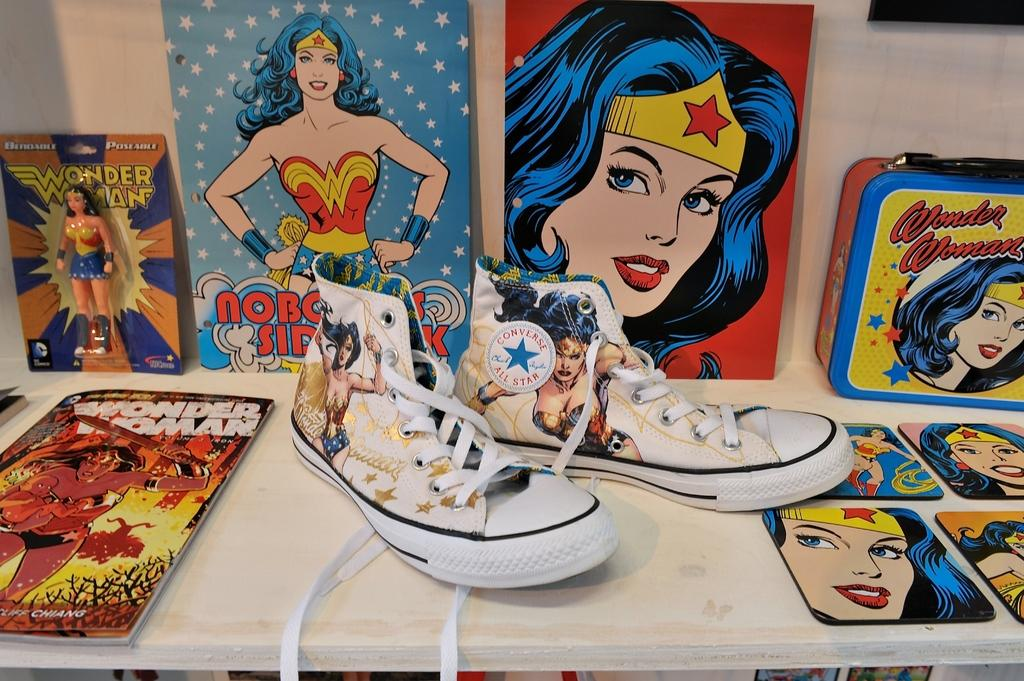What type of footwear is visible in the image? There is a pair of shoes in the image. What else can be seen on the shelf besides the shoes? There are books and a box visible in the image. How are the items arranged in the image? All items are arranged on a shelf. How many pizzas are stacked on top of the books in the image? There are no pizzas present in the image; it only features a pair of shoes, books, and a box arranged on a shelf. 